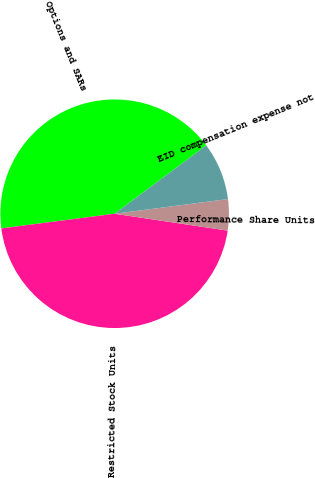Convert chart. <chart><loc_0><loc_0><loc_500><loc_500><pie_chart><fcel>Options and SARs<fcel>Restricted Stock Units<fcel>Performance Share Units<fcel>EID compensation expense not<nl><fcel>41.85%<fcel>45.59%<fcel>4.41%<fcel>8.15%<nl></chart> 